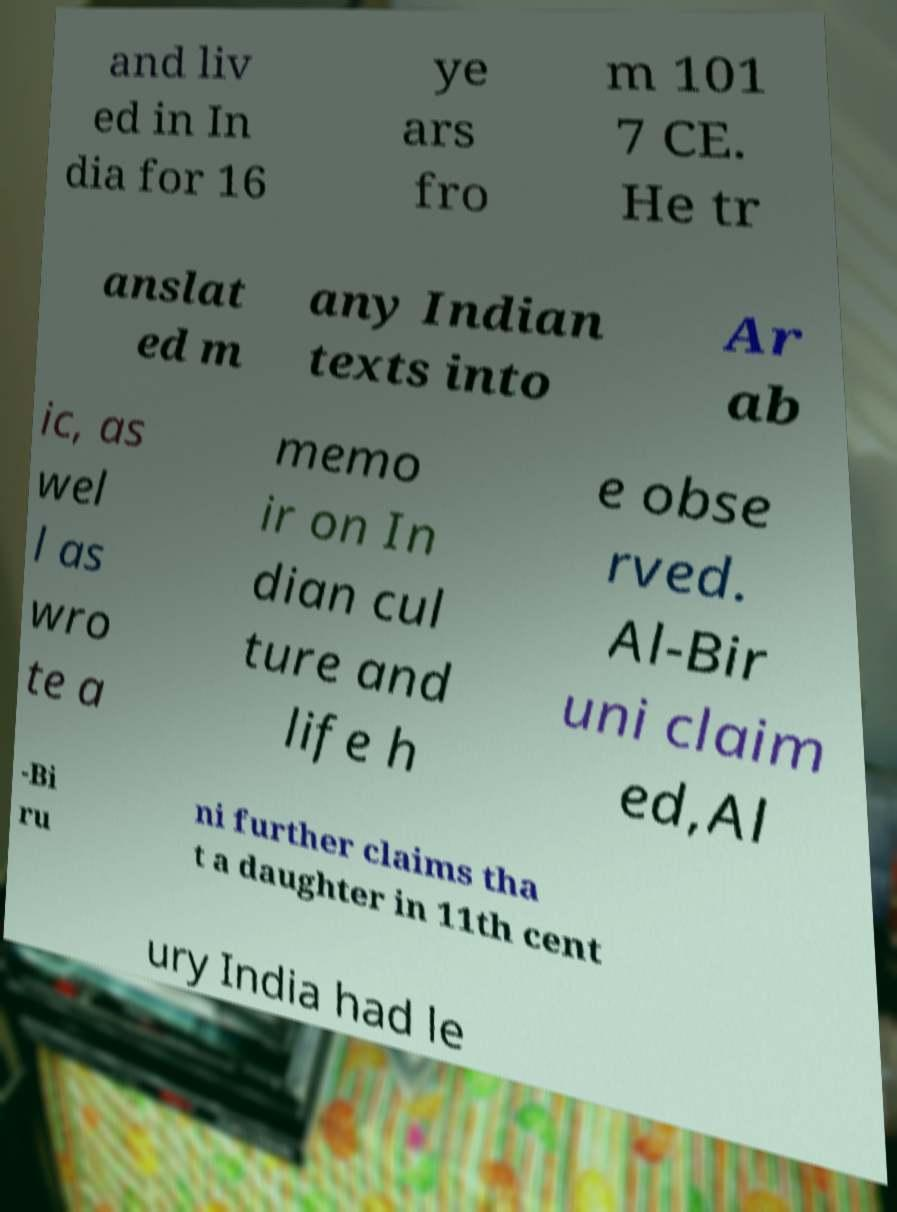I need the written content from this picture converted into text. Can you do that? and liv ed in In dia for 16 ye ars fro m 101 7 CE. He tr anslat ed m any Indian texts into Ar ab ic, as wel l as wro te a memo ir on In dian cul ture and life h e obse rved. Al-Bir uni claim ed,Al -Bi ru ni further claims tha t a daughter in 11th cent ury India had le 